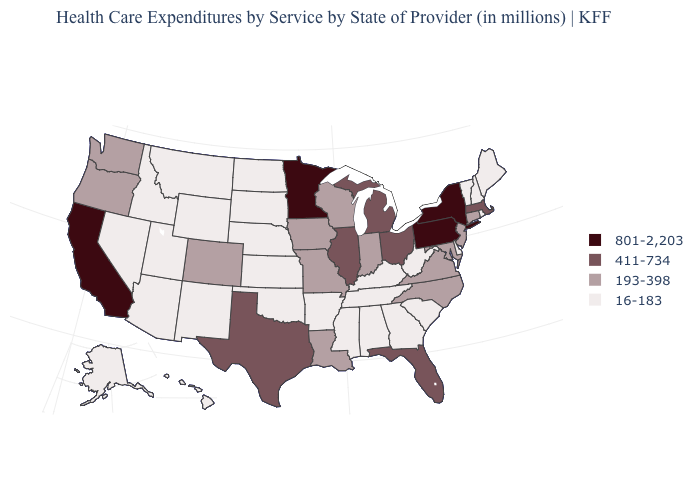Name the states that have a value in the range 16-183?
Keep it brief. Alabama, Alaska, Arizona, Arkansas, Delaware, Georgia, Hawaii, Idaho, Kansas, Kentucky, Maine, Mississippi, Montana, Nebraska, Nevada, New Hampshire, New Mexico, North Dakota, Oklahoma, Rhode Island, South Carolina, South Dakota, Tennessee, Utah, Vermont, West Virginia, Wyoming. What is the value of Idaho?
Quick response, please. 16-183. Does the map have missing data?
Quick response, please. No. Which states have the highest value in the USA?
Write a very short answer. California, Minnesota, New York, Pennsylvania. Name the states that have a value in the range 801-2,203?
Write a very short answer. California, Minnesota, New York, Pennsylvania. What is the highest value in the MidWest ?
Keep it brief. 801-2,203. What is the value of Maryland?
Write a very short answer. 193-398. Name the states that have a value in the range 801-2,203?
Give a very brief answer. California, Minnesota, New York, Pennsylvania. What is the highest value in the West ?
Quick response, please. 801-2,203. What is the lowest value in the Northeast?
Keep it brief. 16-183. What is the value of Virginia?
Short answer required. 193-398. Name the states that have a value in the range 16-183?
Quick response, please. Alabama, Alaska, Arizona, Arkansas, Delaware, Georgia, Hawaii, Idaho, Kansas, Kentucky, Maine, Mississippi, Montana, Nebraska, Nevada, New Hampshire, New Mexico, North Dakota, Oklahoma, Rhode Island, South Carolina, South Dakota, Tennessee, Utah, Vermont, West Virginia, Wyoming. Name the states that have a value in the range 193-398?
Keep it brief. Colorado, Connecticut, Indiana, Iowa, Louisiana, Maryland, Missouri, New Jersey, North Carolina, Oregon, Virginia, Washington, Wisconsin. What is the value of Oklahoma?
Answer briefly. 16-183. Does Arkansas have the highest value in the USA?
Be succinct. No. 